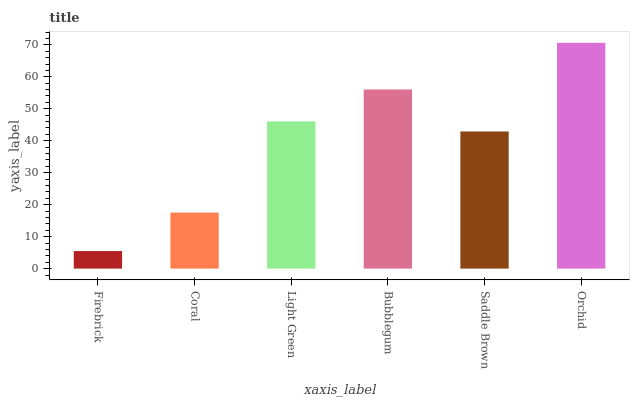Is Firebrick the minimum?
Answer yes or no. Yes. Is Orchid the maximum?
Answer yes or no. Yes. Is Coral the minimum?
Answer yes or no. No. Is Coral the maximum?
Answer yes or no. No. Is Coral greater than Firebrick?
Answer yes or no. Yes. Is Firebrick less than Coral?
Answer yes or no. Yes. Is Firebrick greater than Coral?
Answer yes or no. No. Is Coral less than Firebrick?
Answer yes or no. No. Is Light Green the high median?
Answer yes or no. Yes. Is Saddle Brown the low median?
Answer yes or no. Yes. Is Saddle Brown the high median?
Answer yes or no. No. Is Bubblegum the low median?
Answer yes or no. No. 